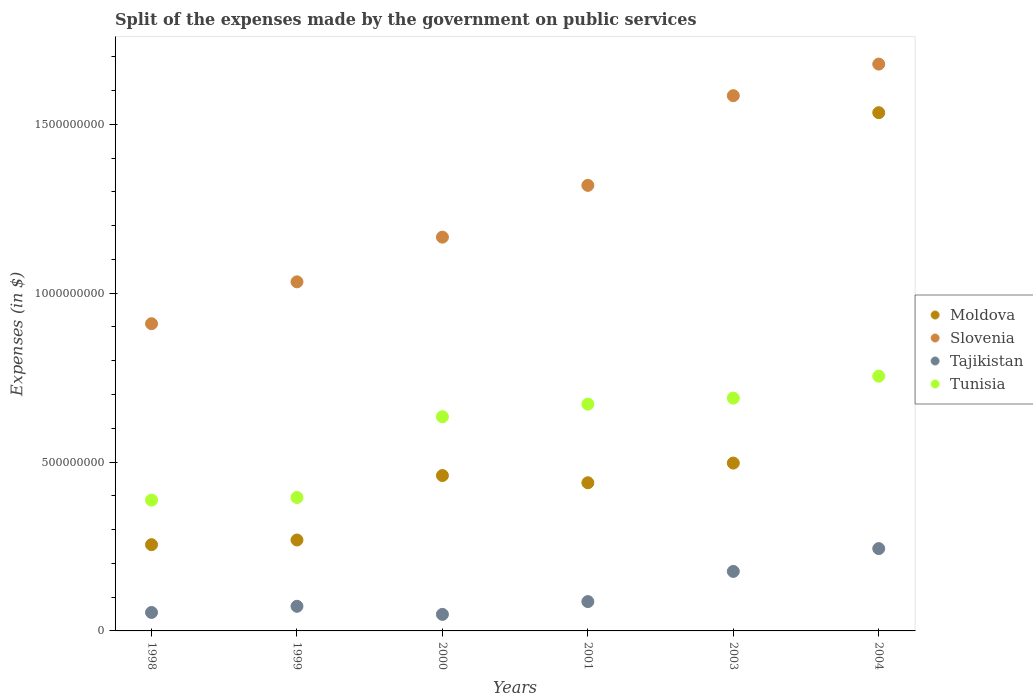How many different coloured dotlines are there?
Give a very brief answer. 4. What is the expenses made by the government on public services in Moldova in 2000?
Your response must be concise. 4.60e+08. Across all years, what is the maximum expenses made by the government on public services in Slovenia?
Your answer should be compact. 1.68e+09. Across all years, what is the minimum expenses made by the government on public services in Tunisia?
Your answer should be compact. 3.87e+08. In which year was the expenses made by the government on public services in Tunisia minimum?
Your answer should be very brief. 1998. What is the total expenses made by the government on public services in Slovenia in the graph?
Your response must be concise. 7.69e+09. What is the difference between the expenses made by the government on public services in Tajikistan in 1998 and that in 1999?
Your response must be concise. -1.82e+07. What is the difference between the expenses made by the government on public services in Moldova in 1998 and the expenses made by the government on public services in Slovenia in 1999?
Ensure brevity in your answer.  -7.78e+08. What is the average expenses made by the government on public services in Moldova per year?
Give a very brief answer. 5.76e+08. In the year 2003, what is the difference between the expenses made by the government on public services in Tajikistan and expenses made by the government on public services in Moldova?
Keep it short and to the point. -3.21e+08. In how many years, is the expenses made by the government on public services in Slovenia greater than 1600000000 $?
Ensure brevity in your answer.  1. What is the ratio of the expenses made by the government on public services in Slovenia in 2001 to that in 2004?
Your answer should be compact. 0.79. Is the expenses made by the government on public services in Slovenia in 1998 less than that in 2004?
Provide a short and direct response. Yes. Is the difference between the expenses made by the government on public services in Tajikistan in 2003 and 2004 greater than the difference between the expenses made by the government on public services in Moldova in 2003 and 2004?
Your answer should be compact. Yes. What is the difference between the highest and the second highest expenses made by the government on public services in Slovenia?
Your answer should be compact. 9.35e+07. What is the difference between the highest and the lowest expenses made by the government on public services in Tunisia?
Your response must be concise. 3.67e+08. In how many years, is the expenses made by the government on public services in Tajikistan greater than the average expenses made by the government on public services in Tajikistan taken over all years?
Give a very brief answer. 2. Is it the case that in every year, the sum of the expenses made by the government on public services in Slovenia and expenses made by the government on public services in Tunisia  is greater than the sum of expenses made by the government on public services in Tajikistan and expenses made by the government on public services in Moldova?
Provide a succinct answer. No. Is the expenses made by the government on public services in Slovenia strictly greater than the expenses made by the government on public services in Tunisia over the years?
Make the answer very short. Yes. Is the expenses made by the government on public services in Tajikistan strictly less than the expenses made by the government on public services in Slovenia over the years?
Your answer should be very brief. Yes. How many dotlines are there?
Offer a very short reply. 4. How many years are there in the graph?
Ensure brevity in your answer.  6. Are the values on the major ticks of Y-axis written in scientific E-notation?
Keep it short and to the point. No. Does the graph contain grids?
Ensure brevity in your answer.  No. Where does the legend appear in the graph?
Your answer should be compact. Center right. What is the title of the graph?
Ensure brevity in your answer.  Split of the expenses made by the government on public services. What is the label or title of the X-axis?
Provide a short and direct response. Years. What is the label or title of the Y-axis?
Keep it short and to the point. Expenses (in $). What is the Expenses (in $) in Moldova in 1998?
Give a very brief answer. 2.55e+08. What is the Expenses (in $) of Slovenia in 1998?
Your answer should be compact. 9.10e+08. What is the Expenses (in $) of Tajikistan in 1998?
Ensure brevity in your answer.  5.47e+07. What is the Expenses (in $) in Tunisia in 1998?
Provide a short and direct response. 3.87e+08. What is the Expenses (in $) in Moldova in 1999?
Your response must be concise. 2.69e+08. What is the Expenses (in $) in Slovenia in 1999?
Provide a short and direct response. 1.03e+09. What is the Expenses (in $) of Tajikistan in 1999?
Your answer should be very brief. 7.29e+07. What is the Expenses (in $) in Tunisia in 1999?
Offer a very short reply. 3.95e+08. What is the Expenses (in $) of Moldova in 2000?
Your answer should be very brief. 4.60e+08. What is the Expenses (in $) in Slovenia in 2000?
Your answer should be compact. 1.17e+09. What is the Expenses (in $) in Tajikistan in 2000?
Ensure brevity in your answer.  4.90e+07. What is the Expenses (in $) of Tunisia in 2000?
Ensure brevity in your answer.  6.34e+08. What is the Expenses (in $) in Moldova in 2001?
Your response must be concise. 4.39e+08. What is the Expenses (in $) of Slovenia in 2001?
Offer a very short reply. 1.32e+09. What is the Expenses (in $) of Tajikistan in 2001?
Make the answer very short. 8.68e+07. What is the Expenses (in $) in Tunisia in 2001?
Your answer should be compact. 6.72e+08. What is the Expenses (in $) of Moldova in 2003?
Provide a succinct answer. 4.97e+08. What is the Expenses (in $) of Slovenia in 2003?
Your answer should be very brief. 1.58e+09. What is the Expenses (in $) in Tajikistan in 2003?
Offer a very short reply. 1.76e+08. What is the Expenses (in $) of Tunisia in 2003?
Give a very brief answer. 6.89e+08. What is the Expenses (in $) in Moldova in 2004?
Your answer should be very brief. 1.53e+09. What is the Expenses (in $) in Slovenia in 2004?
Provide a succinct answer. 1.68e+09. What is the Expenses (in $) of Tajikistan in 2004?
Provide a short and direct response. 2.44e+08. What is the Expenses (in $) in Tunisia in 2004?
Provide a short and direct response. 7.54e+08. Across all years, what is the maximum Expenses (in $) in Moldova?
Your response must be concise. 1.53e+09. Across all years, what is the maximum Expenses (in $) of Slovenia?
Make the answer very short. 1.68e+09. Across all years, what is the maximum Expenses (in $) of Tajikistan?
Make the answer very short. 2.44e+08. Across all years, what is the maximum Expenses (in $) in Tunisia?
Your response must be concise. 7.54e+08. Across all years, what is the minimum Expenses (in $) of Moldova?
Your answer should be compact. 2.55e+08. Across all years, what is the minimum Expenses (in $) in Slovenia?
Provide a succinct answer. 9.10e+08. Across all years, what is the minimum Expenses (in $) of Tajikistan?
Ensure brevity in your answer.  4.90e+07. Across all years, what is the minimum Expenses (in $) in Tunisia?
Keep it short and to the point. 3.87e+08. What is the total Expenses (in $) in Moldova in the graph?
Provide a short and direct response. 3.45e+09. What is the total Expenses (in $) of Slovenia in the graph?
Make the answer very short. 7.69e+09. What is the total Expenses (in $) in Tajikistan in the graph?
Give a very brief answer. 6.83e+08. What is the total Expenses (in $) of Tunisia in the graph?
Offer a very short reply. 3.53e+09. What is the difference between the Expenses (in $) of Moldova in 1998 and that in 1999?
Keep it short and to the point. -1.38e+07. What is the difference between the Expenses (in $) in Slovenia in 1998 and that in 1999?
Ensure brevity in your answer.  -1.24e+08. What is the difference between the Expenses (in $) in Tajikistan in 1998 and that in 1999?
Keep it short and to the point. -1.82e+07. What is the difference between the Expenses (in $) in Tunisia in 1998 and that in 1999?
Your answer should be very brief. -7.80e+06. What is the difference between the Expenses (in $) in Moldova in 1998 and that in 2000?
Offer a terse response. -2.05e+08. What is the difference between the Expenses (in $) in Slovenia in 1998 and that in 2000?
Give a very brief answer. -2.56e+08. What is the difference between the Expenses (in $) of Tajikistan in 1998 and that in 2000?
Make the answer very short. 5.65e+06. What is the difference between the Expenses (in $) in Tunisia in 1998 and that in 2000?
Ensure brevity in your answer.  -2.47e+08. What is the difference between the Expenses (in $) of Moldova in 1998 and that in 2001?
Make the answer very short. -1.83e+08. What is the difference between the Expenses (in $) of Slovenia in 1998 and that in 2001?
Ensure brevity in your answer.  -4.10e+08. What is the difference between the Expenses (in $) of Tajikistan in 1998 and that in 2001?
Offer a very short reply. -3.22e+07. What is the difference between the Expenses (in $) of Tunisia in 1998 and that in 2001?
Provide a short and direct response. -2.84e+08. What is the difference between the Expenses (in $) of Moldova in 1998 and that in 2003?
Give a very brief answer. -2.42e+08. What is the difference between the Expenses (in $) in Slovenia in 1998 and that in 2003?
Your answer should be very brief. -6.75e+08. What is the difference between the Expenses (in $) in Tajikistan in 1998 and that in 2003?
Offer a very short reply. -1.22e+08. What is the difference between the Expenses (in $) of Tunisia in 1998 and that in 2003?
Your response must be concise. -3.02e+08. What is the difference between the Expenses (in $) in Moldova in 1998 and that in 2004?
Keep it short and to the point. -1.28e+09. What is the difference between the Expenses (in $) of Slovenia in 1998 and that in 2004?
Your answer should be very brief. -7.69e+08. What is the difference between the Expenses (in $) of Tajikistan in 1998 and that in 2004?
Your answer should be compact. -1.89e+08. What is the difference between the Expenses (in $) of Tunisia in 1998 and that in 2004?
Your answer should be compact. -3.67e+08. What is the difference between the Expenses (in $) of Moldova in 1999 and that in 2000?
Keep it short and to the point. -1.91e+08. What is the difference between the Expenses (in $) in Slovenia in 1999 and that in 2000?
Your response must be concise. -1.32e+08. What is the difference between the Expenses (in $) in Tajikistan in 1999 and that in 2000?
Keep it short and to the point. 2.39e+07. What is the difference between the Expenses (in $) in Tunisia in 1999 and that in 2000?
Your answer should be very brief. -2.39e+08. What is the difference between the Expenses (in $) in Moldova in 1999 and that in 2001?
Your answer should be very brief. -1.70e+08. What is the difference between the Expenses (in $) of Slovenia in 1999 and that in 2001?
Ensure brevity in your answer.  -2.86e+08. What is the difference between the Expenses (in $) in Tajikistan in 1999 and that in 2001?
Your answer should be compact. -1.39e+07. What is the difference between the Expenses (in $) of Tunisia in 1999 and that in 2001?
Offer a very short reply. -2.76e+08. What is the difference between the Expenses (in $) of Moldova in 1999 and that in 2003?
Keep it short and to the point. -2.28e+08. What is the difference between the Expenses (in $) of Slovenia in 1999 and that in 2003?
Provide a short and direct response. -5.51e+08. What is the difference between the Expenses (in $) in Tajikistan in 1999 and that in 2003?
Your response must be concise. -1.03e+08. What is the difference between the Expenses (in $) of Tunisia in 1999 and that in 2003?
Offer a very short reply. -2.94e+08. What is the difference between the Expenses (in $) in Moldova in 1999 and that in 2004?
Your answer should be very brief. -1.27e+09. What is the difference between the Expenses (in $) of Slovenia in 1999 and that in 2004?
Offer a terse response. -6.45e+08. What is the difference between the Expenses (in $) of Tajikistan in 1999 and that in 2004?
Provide a short and direct response. -1.71e+08. What is the difference between the Expenses (in $) of Tunisia in 1999 and that in 2004?
Your response must be concise. -3.59e+08. What is the difference between the Expenses (in $) of Moldova in 2000 and that in 2001?
Offer a very short reply. 2.14e+07. What is the difference between the Expenses (in $) of Slovenia in 2000 and that in 2001?
Make the answer very short. -1.53e+08. What is the difference between the Expenses (in $) in Tajikistan in 2000 and that in 2001?
Provide a short and direct response. -3.78e+07. What is the difference between the Expenses (in $) of Tunisia in 2000 and that in 2001?
Make the answer very short. -3.73e+07. What is the difference between the Expenses (in $) of Moldova in 2000 and that in 2003?
Make the answer very short. -3.69e+07. What is the difference between the Expenses (in $) in Slovenia in 2000 and that in 2003?
Ensure brevity in your answer.  -4.19e+08. What is the difference between the Expenses (in $) of Tajikistan in 2000 and that in 2003?
Your answer should be compact. -1.27e+08. What is the difference between the Expenses (in $) in Tunisia in 2000 and that in 2003?
Provide a succinct answer. -5.52e+07. What is the difference between the Expenses (in $) in Moldova in 2000 and that in 2004?
Your answer should be compact. -1.07e+09. What is the difference between the Expenses (in $) in Slovenia in 2000 and that in 2004?
Offer a very short reply. -5.12e+08. What is the difference between the Expenses (in $) in Tajikistan in 2000 and that in 2004?
Keep it short and to the point. -1.95e+08. What is the difference between the Expenses (in $) in Tunisia in 2000 and that in 2004?
Offer a very short reply. -1.20e+08. What is the difference between the Expenses (in $) of Moldova in 2001 and that in 2003?
Give a very brief answer. -5.83e+07. What is the difference between the Expenses (in $) of Slovenia in 2001 and that in 2003?
Your answer should be compact. -2.66e+08. What is the difference between the Expenses (in $) in Tajikistan in 2001 and that in 2003?
Provide a short and direct response. -8.94e+07. What is the difference between the Expenses (in $) in Tunisia in 2001 and that in 2003?
Your answer should be compact. -1.79e+07. What is the difference between the Expenses (in $) of Moldova in 2001 and that in 2004?
Offer a terse response. -1.10e+09. What is the difference between the Expenses (in $) in Slovenia in 2001 and that in 2004?
Keep it short and to the point. -3.59e+08. What is the difference between the Expenses (in $) in Tajikistan in 2001 and that in 2004?
Offer a very short reply. -1.57e+08. What is the difference between the Expenses (in $) in Tunisia in 2001 and that in 2004?
Offer a terse response. -8.29e+07. What is the difference between the Expenses (in $) of Moldova in 2003 and that in 2004?
Your response must be concise. -1.04e+09. What is the difference between the Expenses (in $) in Slovenia in 2003 and that in 2004?
Your response must be concise. -9.35e+07. What is the difference between the Expenses (in $) in Tajikistan in 2003 and that in 2004?
Your response must be concise. -6.76e+07. What is the difference between the Expenses (in $) in Tunisia in 2003 and that in 2004?
Provide a short and direct response. -6.50e+07. What is the difference between the Expenses (in $) of Moldova in 1998 and the Expenses (in $) of Slovenia in 1999?
Ensure brevity in your answer.  -7.78e+08. What is the difference between the Expenses (in $) in Moldova in 1998 and the Expenses (in $) in Tajikistan in 1999?
Your answer should be very brief. 1.82e+08. What is the difference between the Expenses (in $) in Moldova in 1998 and the Expenses (in $) in Tunisia in 1999?
Make the answer very short. -1.40e+08. What is the difference between the Expenses (in $) in Slovenia in 1998 and the Expenses (in $) in Tajikistan in 1999?
Your response must be concise. 8.37e+08. What is the difference between the Expenses (in $) in Slovenia in 1998 and the Expenses (in $) in Tunisia in 1999?
Provide a succinct answer. 5.15e+08. What is the difference between the Expenses (in $) of Tajikistan in 1998 and the Expenses (in $) of Tunisia in 1999?
Provide a short and direct response. -3.40e+08. What is the difference between the Expenses (in $) of Moldova in 1998 and the Expenses (in $) of Slovenia in 2000?
Provide a short and direct response. -9.11e+08. What is the difference between the Expenses (in $) in Moldova in 1998 and the Expenses (in $) in Tajikistan in 2000?
Give a very brief answer. 2.06e+08. What is the difference between the Expenses (in $) of Moldova in 1998 and the Expenses (in $) of Tunisia in 2000?
Offer a very short reply. -3.79e+08. What is the difference between the Expenses (in $) in Slovenia in 1998 and the Expenses (in $) in Tajikistan in 2000?
Offer a very short reply. 8.61e+08. What is the difference between the Expenses (in $) in Slovenia in 1998 and the Expenses (in $) in Tunisia in 2000?
Provide a succinct answer. 2.75e+08. What is the difference between the Expenses (in $) of Tajikistan in 1998 and the Expenses (in $) of Tunisia in 2000?
Provide a short and direct response. -5.80e+08. What is the difference between the Expenses (in $) of Moldova in 1998 and the Expenses (in $) of Slovenia in 2001?
Give a very brief answer. -1.06e+09. What is the difference between the Expenses (in $) in Moldova in 1998 and the Expenses (in $) in Tajikistan in 2001?
Provide a succinct answer. 1.69e+08. What is the difference between the Expenses (in $) of Moldova in 1998 and the Expenses (in $) of Tunisia in 2001?
Provide a succinct answer. -4.16e+08. What is the difference between the Expenses (in $) of Slovenia in 1998 and the Expenses (in $) of Tajikistan in 2001?
Your answer should be compact. 8.23e+08. What is the difference between the Expenses (in $) of Slovenia in 1998 and the Expenses (in $) of Tunisia in 2001?
Provide a short and direct response. 2.38e+08. What is the difference between the Expenses (in $) of Tajikistan in 1998 and the Expenses (in $) of Tunisia in 2001?
Provide a short and direct response. -6.17e+08. What is the difference between the Expenses (in $) in Moldova in 1998 and the Expenses (in $) in Slovenia in 2003?
Keep it short and to the point. -1.33e+09. What is the difference between the Expenses (in $) of Moldova in 1998 and the Expenses (in $) of Tajikistan in 2003?
Offer a terse response. 7.92e+07. What is the difference between the Expenses (in $) in Moldova in 1998 and the Expenses (in $) in Tunisia in 2003?
Your answer should be very brief. -4.34e+08. What is the difference between the Expenses (in $) in Slovenia in 1998 and the Expenses (in $) in Tajikistan in 2003?
Your answer should be very brief. 7.33e+08. What is the difference between the Expenses (in $) in Slovenia in 1998 and the Expenses (in $) in Tunisia in 2003?
Your response must be concise. 2.20e+08. What is the difference between the Expenses (in $) in Tajikistan in 1998 and the Expenses (in $) in Tunisia in 2003?
Offer a terse response. -6.35e+08. What is the difference between the Expenses (in $) of Moldova in 1998 and the Expenses (in $) of Slovenia in 2004?
Make the answer very short. -1.42e+09. What is the difference between the Expenses (in $) of Moldova in 1998 and the Expenses (in $) of Tajikistan in 2004?
Keep it short and to the point. 1.16e+07. What is the difference between the Expenses (in $) of Moldova in 1998 and the Expenses (in $) of Tunisia in 2004?
Make the answer very short. -4.99e+08. What is the difference between the Expenses (in $) in Slovenia in 1998 and the Expenses (in $) in Tajikistan in 2004?
Your response must be concise. 6.66e+08. What is the difference between the Expenses (in $) of Slovenia in 1998 and the Expenses (in $) of Tunisia in 2004?
Your answer should be very brief. 1.55e+08. What is the difference between the Expenses (in $) in Tajikistan in 1998 and the Expenses (in $) in Tunisia in 2004?
Make the answer very short. -7.00e+08. What is the difference between the Expenses (in $) in Moldova in 1999 and the Expenses (in $) in Slovenia in 2000?
Your answer should be compact. -8.97e+08. What is the difference between the Expenses (in $) in Moldova in 1999 and the Expenses (in $) in Tajikistan in 2000?
Keep it short and to the point. 2.20e+08. What is the difference between the Expenses (in $) in Moldova in 1999 and the Expenses (in $) in Tunisia in 2000?
Your answer should be compact. -3.65e+08. What is the difference between the Expenses (in $) of Slovenia in 1999 and the Expenses (in $) of Tajikistan in 2000?
Ensure brevity in your answer.  9.85e+08. What is the difference between the Expenses (in $) of Slovenia in 1999 and the Expenses (in $) of Tunisia in 2000?
Make the answer very short. 3.99e+08. What is the difference between the Expenses (in $) of Tajikistan in 1999 and the Expenses (in $) of Tunisia in 2000?
Keep it short and to the point. -5.61e+08. What is the difference between the Expenses (in $) of Moldova in 1999 and the Expenses (in $) of Slovenia in 2001?
Your answer should be very brief. -1.05e+09. What is the difference between the Expenses (in $) in Moldova in 1999 and the Expenses (in $) in Tajikistan in 2001?
Keep it short and to the point. 1.82e+08. What is the difference between the Expenses (in $) in Moldova in 1999 and the Expenses (in $) in Tunisia in 2001?
Make the answer very short. -4.02e+08. What is the difference between the Expenses (in $) of Slovenia in 1999 and the Expenses (in $) of Tajikistan in 2001?
Make the answer very short. 9.47e+08. What is the difference between the Expenses (in $) in Slovenia in 1999 and the Expenses (in $) in Tunisia in 2001?
Offer a very short reply. 3.62e+08. What is the difference between the Expenses (in $) of Tajikistan in 1999 and the Expenses (in $) of Tunisia in 2001?
Make the answer very short. -5.99e+08. What is the difference between the Expenses (in $) in Moldova in 1999 and the Expenses (in $) in Slovenia in 2003?
Ensure brevity in your answer.  -1.32e+09. What is the difference between the Expenses (in $) of Moldova in 1999 and the Expenses (in $) of Tajikistan in 2003?
Your answer should be compact. 9.30e+07. What is the difference between the Expenses (in $) of Moldova in 1999 and the Expenses (in $) of Tunisia in 2003?
Your answer should be very brief. -4.20e+08. What is the difference between the Expenses (in $) in Slovenia in 1999 and the Expenses (in $) in Tajikistan in 2003?
Make the answer very short. 8.57e+08. What is the difference between the Expenses (in $) in Slovenia in 1999 and the Expenses (in $) in Tunisia in 2003?
Offer a terse response. 3.44e+08. What is the difference between the Expenses (in $) of Tajikistan in 1999 and the Expenses (in $) of Tunisia in 2003?
Your answer should be compact. -6.16e+08. What is the difference between the Expenses (in $) of Moldova in 1999 and the Expenses (in $) of Slovenia in 2004?
Your answer should be compact. -1.41e+09. What is the difference between the Expenses (in $) of Moldova in 1999 and the Expenses (in $) of Tajikistan in 2004?
Your answer should be compact. 2.54e+07. What is the difference between the Expenses (in $) in Moldova in 1999 and the Expenses (in $) in Tunisia in 2004?
Provide a succinct answer. -4.85e+08. What is the difference between the Expenses (in $) in Slovenia in 1999 and the Expenses (in $) in Tajikistan in 2004?
Your answer should be compact. 7.90e+08. What is the difference between the Expenses (in $) in Slovenia in 1999 and the Expenses (in $) in Tunisia in 2004?
Offer a terse response. 2.79e+08. What is the difference between the Expenses (in $) of Tajikistan in 1999 and the Expenses (in $) of Tunisia in 2004?
Give a very brief answer. -6.81e+08. What is the difference between the Expenses (in $) of Moldova in 2000 and the Expenses (in $) of Slovenia in 2001?
Give a very brief answer. -8.59e+08. What is the difference between the Expenses (in $) of Moldova in 2000 and the Expenses (in $) of Tajikistan in 2001?
Make the answer very short. 3.73e+08. What is the difference between the Expenses (in $) in Moldova in 2000 and the Expenses (in $) in Tunisia in 2001?
Provide a succinct answer. -2.11e+08. What is the difference between the Expenses (in $) of Slovenia in 2000 and the Expenses (in $) of Tajikistan in 2001?
Offer a very short reply. 1.08e+09. What is the difference between the Expenses (in $) of Slovenia in 2000 and the Expenses (in $) of Tunisia in 2001?
Your answer should be compact. 4.94e+08. What is the difference between the Expenses (in $) of Tajikistan in 2000 and the Expenses (in $) of Tunisia in 2001?
Keep it short and to the point. -6.22e+08. What is the difference between the Expenses (in $) of Moldova in 2000 and the Expenses (in $) of Slovenia in 2003?
Your response must be concise. -1.12e+09. What is the difference between the Expenses (in $) in Moldova in 2000 and the Expenses (in $) in Tajikistan in 2003?
Keep it short and to the point. 2.84e+08. What is the difference between the Expenses (in $) in Moldova in 2000 and the Expenses (in $) in Tunisia in 2003?
Your response must be concise. -2.29e+08. What is the difference between the Expenses (in $) in Slovenia in 2000 and the Expenses (in $) in Tajikistan in 2003?
Provide a short and direct response. 9.90e+08. What is the difference between the Expenses (in $) in Slovenia in 2000 and the Expenses (in $) in Tunisia in 2003?
Ensure brevity in your answer.  4.77e+08. What is the difference between the Expenses (in $) of Tajikistan in 2000 and the Expenses (in $) of Tunisia in 2003?
Offer a very short reply. -6.40e+08. What is the difference between the Expenses (in $) in Moldova in 2000 and the Expenses (in $) in Slovenia in 2004?
Your answer should be compact. -1.22e+09. What is the difference between the Expenses (in $) of Moldova in 2000 and the Expenses (in $) of Tajikistan in 2004?
Keep it short and to the point. 2.16e+08. What is the difference between the Expenses (in $) of Moldova in 2000 and the Expenses (in $) of Tunisia in 2004?
Offer a terse response. -2.94e+08. What is the difference between the Expenses (in $) in Slovenia in 2000 and the Expenses (in $) in Tajikistan in 2004?
Provide a short and direct response. 9.22e+08. What is the difference between the Expenses (in $) in Slovenia in 2000 and the Expenses (in $) in Tunisia in 2004?
Keep it short and to the point. 4.12e+08. What is the difference between the Expenses (in $) in Tajikistan in 2000 and the Expenses (in $) in Tunisia in 2004?
Your answer should be very brief. -7.05e+08. What is the difference between the Expenses (in $) of Moldova in 2001 and the Expenses (in $) of Slovenia in 2003?
Your response must be concise. -1.15e+09. What is the difference between the Expenses (in $) of Moldova in 2001 and the Expenses (in $) of Tajikistan in 2003?
Provide a succinct answer. 2.62e+08. What is the difference between the Expenses (in $) of Moldova in 2001 and the Expenses (in $) of Tunisia in 2003?
Make the answer very short. -2.51e+08. What is the difference between the Expenses (in $) of Slovenia in 2001 and the Expenses (in $) of Tajikistan in 2003?
Provide a short and direct response. 1.14e+09. What is the difference between the Expenses (in $) of Slovenia in 2001 and the Expenses (in $) of Tunisia in 2003?
Your answer should be very brief. 6.30e+08. What is the difference between the Expenses (in $) in Tajikistan in 2001 and the Expenses (in $) in Tunisia in 2003?
Ensure brevity in your answer.  -6.03e+08. What is the difference between the Expenses (in $) in Moldova in 2001 and the Expenses (in $) in Slovenia in 2004?
Keep it short and to the point. -1.24e+09. What is the difference between the Expenses (in $) in Moldova in 2001 and the Expenses (in $) in Tajikistan in 2004?
Give a very brief answer. 1.95e+08. What is the difference between the Expenses (in $) in Moldova in 2001 and the Expenses (in $) in Tunisia in 2004?
Keep it short and to the point. -3.16e+08. What is the difference between the Expenses (in $) in Slovenia in 2001 and the Expenses (in $) in Tajikistan in 2004?
Keep it short and to the point. 1.08e+09. What is the difference between the Expenses (in $) of Slovenia in 2001 and the Expenses (in $) of Tunisia in 2004?
Give a very brief answer. 5.65e+08. What is the difference between the Expenses (in $) in Tajikistan in 2001 and the Expenses (in $) in Tunisia in 2004?
Give a very brief answer. -6.68e+08. What is the difference between the Expenses (in $) of Moldova in 2003 and the Expenses (in $) of Slovenia in 2004?
Offer a very short reply. -1.18e+09. What is the difference between the Expenses (in $) of Moldova in 2003 and the Expenses (in $) of Tajikistan in 2004?
Provide a short and direct response. 2.53e+08. What is the difference between the Expenses (in $) in Moldova in 2003 and the Expenses (in $) in Tunisia in 2004?
Provide a short and direct response. -2.57e+08. What is the difference between the Expenses (in $) of Slovenia in 2003 and the Expenses (in $) of Tajikistan in 2004?
Provide a short and direct response. 1.34e+09. What is the difference between the Expenses (in $) in Slovenia in 2003 and the Expenses (in $) in Tunisia in 2004?
Make the answer very short. 8.30e+08. What is the difference between the Expenses (in $) in Tajikistan in 2003 and the Expenses (in $) in Tunisia in 2004?
Keep it short and to the point. -5.78e+08. What is the average Expenses (in $) of Moldova per year?
Offer a very short reply. 5.76e+08. What is the average Expenses (in $) in Slovenia per year?
Provide a short and direct response. 1.28e+09. What is the average Expenses (in $) in Tajikistan per year?
Your response must be concise. 1.14e+08. What is the average Expenses (in $) in Tunisia per year?
Offer a terse response. 5.89e+08. In the year 1998, what is the difference between the Expenses (in $) in Moldova and Expenses (in $) in Slovenia?
Keep it short and to the point. -6.54e+08. In the year 1998, what is the difference between the Expenses (in $) in Moldova and Expenses (in $) in Tajikistan?
Provide a short and direct response. 2.01e+08. In the year 1998, what is the difference between the Expenses (in $) in Moldova and Expenses (in $) in Tunisia?
Your answer should be very brief. -1.32e+08. In the year 1998, what is the difference between the Expenses (in $) in Slovenia and Expenses (in $) in Tajikistan?
Make the answer very short. 8.55e+08. In the year 1998, what is the difference between the Expenses (in $) in Slovenia and Expenses (in $) in Tunisia?
Your answer should be very brief. 5.22e+08. In the year 1998, what is the difference between the Expenses (in $) in Tajikistan and Expenses (in $) in Tunisia?
Provide a short and direct response. -3.33e+08. In the year 1999, what is the difference between the Expenses (in $) in Moldova and Expenses (in $) in Slovenia?
Keep it short and to the point. -7.64e+08. In the year 1999, what is the difference between the Expenses (in $) in Moldova and Expenses (in $) in Tajikistan?
Offer a very short reply. 1.96e+08. In the year 1999, what is the difference between the Expenses (in $) of Moldova and Expenses (in $) of Tunisia?
Provide a succinct answer. -1.26e+08. In the year 1999, what is the difference between the Expenses (in $) of Slovenia and Expenses (in $) of Tajikistan?
Give a very brief answer. 9.61e+08. In the year 1999, what is the difference between the Expenses (in $) in Slovenia and Expenses (in $) in Tunisia?
Offer a terse response. 6.39e+08. In the year 1999, what is the difference between the Expenses (in $) of Tajikistan and Expenses (in $) of Tunisia?
Make the answer very short. -3.22e+08. In the year 2000, what is the difference between the Expenses (in $) of Moldova and Expenses (in $) of Slovenia?
Provide a short and direct response. -7.06e+08. In the year 2000, what is the difference between the Expenses (in $) of Moldova and Expenses (in $) of Tajikistan?
Your answer should be compact. 4.11e+08. In the year 2000, what is the difference between the Expenses (in $) of Moldova and Expenses (in $) of Tunisia?
Provide a short and direct response. -1.74e+08. In the year 2000, what is the difference between the Expenses (in $) in Slovenia and Expenses (in $) in Tajikistan?
Offer a terse response. 1.12e+09. In the year 2000, what is the difference between the Expenses (in $) of Slovenia and Expenses (in $) of Tunisia?
Offer a very short reply. 5.32e+08. In the year 2000, what is the difference between the Expenses (in $) of Tajikistan and Expenses (in $) of Tunisia?
Keep it short and to the point. -5.85e+08. In the year 2001, what is the difference between the Expenses (in $) in Moldova and Expenses (in $) in Slovenia?
Provide a succinct answer. -8.81e+08. In the year 2001, what is the difference between the Expenses (in $) in Moldova and Expenses (in $) in Tajikistan?
Your answer should be compact. 3.52e+08. In the year 2001, what is the difference between the Expenses (in $) of Moldova and Expenses (in $) of Tunisia?
Make the answer very short. -2.33e+08. In the year 2001, what is the difference between the Expenses (in $) in Slovenia and Expenses (in $) in Tajikistan?
Keep it short and to the point. 1.23e+09. In the year 2001, what is the difference between the Expenses (in $) in Slovenia and Expenses (in $) in Tunisia?
Ensure brevity in your answer.  6.48e+08. In the year 2001, what is the difference between the Expenses (in $) of Tajikistan and Expenses (in $) of Tunisia?
Offer a very short reply. -5.85e+08. In the year 2003, what is the difference between the Expenses (in $) in Moldova and Expenses (in $) in Slovenia?
Give a very brief answer. -1.09e+09. In the year 2003, what is the difference between the Expenses (in $) in Moldova and Expenses (in $) in Tajikistan?
Your response must be concise. 3.21e+08. In the year 2003, what is the difference between the Expenses (in $) in Moldova and Expenses (in $) in Tunisia?
Offer a very short reply. -1.92e+08. In the year 2003, what is the difference between the Expenses (in $) in Slovenia and Expenses (in $) in Tajikistan?
Keep it short and to the point. 1.41e+09. In the year 2003, what is the difference between the Expenses (in $) in Slovenia and Expenses (in $) in Tunisia?
Your answer should be very brief. 8.95e+08. In the year 2003, what is the difference between the Expenses (in $) in Tajikistan and Expenses (in $) in Tunisia?
Give a very brief answer. -5.13e+08. In the year 2004, what is the difference between the Expenses (in $) of Moldova and Expenses (in $) of Slovenia?
Your answer should be very brief. -1.44e+08. In the year 2004, what is the difference between the Expenses (in $) in Moldova and Expenses (in $) in Tajikistan?
Your answer should be very brief. 1.29e+09. In the year 2004, what is the difference between the Expenses (in $) of Moldova and Expenses (in $) of Tunisia?
Give a very brief answer. 7.80e+08. In the year 2004, what is the difference between the Expenses (in $) of Slovenia and Expenses (in $) of Tajikistan?
Your answer should be very brief. 1.43e+09. In the year 2004, what is the difference between the Expenses (in $) of Slovenia and Expenses (in $) of Tunisia?
Give a very brief answer. 9.24e+08. In the year 2004, what is the difference between the Expenses (in $) of Tajikistan and Expenses (in $) of Tunisia?
Your answer should be very brief. -5.11e+08. What is the ratio of the Expenses (in $) of Moldova in 1998 to that in 1999?
Ensure brevity in your answer.  0.95. What is the ratio of the Expenses (in $) in Slovenia in 1998 to that in 1999?
Offer a terse response. 0.88. What is the ratio of the Expenses (in $) in Tajikistan in 1998 to that in 1999?
Your response must be concise. 0.75. What is the ratio of the Expenses (in $) in Tunisia in 1998 to that in 1999?
Ensure brevity in your answer.  0.98. What is the ratio of the Expenses (in $) of Moldova in 1998 to that in 2000?
Ensure brevity in your answer.  0.56. What is the ratio of the Expenses (in $) in Slovenia in 1998 to that in 2000?
Give a very brief answer. 0.78. What is the ratio of the Expenses (in $) of Tajikistan in 1998 to that in 2000?
Your answer should be compact. 1.12. What is the ratio of the Expenses (in $) in Tunisia in 1998 to that in 2000?
Make the answer very short. 0.61. What is the ratio of the Expenses (in $) in Moldova in 1998 to that in 2001?
Your answer should be very brief. 0.58. What is the ratio of the Expenses (in $) of Slovenia in 1998 to that in 2001?
Provide a short and direct response. 0.69. What is the ratio of the Expenses (in $) in Tajikistan in 1998 to that in 2001?
Keep it short and to the point. 0.63. What is the ratio of the Expenses (in $) of Tunisia in 1998 to that in 2001?
Keep it short and to the point. 0.58. What is the ratio of the Expenses (in $) in Moldova in 1998 to that in 2003?
Provide a short and direct response. 0.51. What is the ratio of the Expenses (in $) in Slovenia in 1998 to that in 2003?
Keep it short and to the point. 0.57. What is the ratio of the Expenses (in $) of Tajikistan in 1998 to that in 2003?
Your answer should be very brief. 0.31. What is the ratio of the Expenses (in $) of Tunisia in 1998 to that in 2003?
Your response must be concise. 0.56. What is the ratio of the Expenses (in $) of Moldova in 1998 to that in 2004?
Make the answer very short. 0.17. What is the ratio of the Expenses (in $) of Slovenia in 1998 to that in 2004?
Provide a short and direct response. 0.54. What is the ratio of the Expenses (in $) in Tajikistan in 1998 to that in 2004?
Give a very brief answer. 0.22. What is the ratio of the Expenses (in $) of Tunisia in 1998 to that in 2004?
Offer a terse response. 0.51. What is the ratio of the Expenses (in $) of Moldova in 1999 to that in 2000?
Provide a succinct answer. 0.59. What is the ratio of the Expenses (in $) of Slovenia in 1999 to that in 2000?
Provide a short and direct response. 0.89. What is the ratio of the Expenses (in $) in Tajikistan in 1999 to that in 2000?
Provide a short and direct response. 1.49. What is the ratio of the Expenses (in $) of Tunisia in 1999 to that in 2000?
Offer a terse response. 0.62. What is the ratio of the Expenses (in $) in Moldova in 1999 to that in 2001?
Ensure brevity in your answer.  0.61. What is the ratio of the Expenses (in $) of Slovenia in 1999 to that in 2001?
Offer a very short reply. 0.78. What is the ratio of the Expenses (in $) of Tajikistan in 1999 to that in 2001?
Keep it short and to the point. 0.84. What is the ratio of the Expenses (in $) of Tunisia in 1999 to that in 2001?
Keep it short and to the point. 0.59. What is the ratio of the Expenses (in $) of Moldova in 1999 to that in 2003?
Ensure brevity in your answer.  0.54. What is the ratio of the Expenses (in $) of Slovenia in 1999 to that in 2003?
Offer a very short reply. 0.65. What is the ratio of the Expenses (in $) in Tajikistan in 1999 to that in 2003?
Your answer should be compact. 0.41. What is the ratio of the Expenses (in $) of Tunisia in 1999 to that in 2003?
Give a very brief answer. 0.57. What is the ratio of the Expenses (in $) in Moldova in 1999 to that in 2004?
Make the answer very short. 0.18. What is the ratio of the Expenses (in $) of Slovenia in 1999 to that in 2004?
Your answer should be compact. 0.62. What is the ratio of the Expenses (in $) in Tajikistan in 1999 to that in 2004?
Provide a short and direct response. 0.3. What is the ratio of the Expenses (in $) in Tunisia in 1999 to that in 2004?
Offer a terse response. 0.52. What is the ratio of the Expenses (in $) in Moldova in 2000 to that in 2001?
Your response must be concise. 1.05. What is the ratio of the Expenses (in $) of Slovenia in 2000 to that in 2001?
Keep it short and to the point. 0.88. What is the ratio of the Expenses (in $) of Tajikistan in 2000 to that in 2001?
Your answer should be compact. 0.56. What is the ratio of the Expenses (in $) of Tunisia in 2000 to that in 2001?
Make the answer very short. 0.94. What is the ratio of the Expenses (in $) of Moldova in 2000 to that in 2003?
Keep it short and to the point. 0.93. What is the ratio of the Expenses (in $) of Slovenia in 2000 to that in 2003?
Give a very brief answer. 0.74. What is the ratio of the Expenses (in $) of Tajikistan in 2000 to that in 2003?
Your answer should be very brief. 0.28. What is the ratio of the Expenses (in $) of Tunisia in 2000 to that in 2003?
Your answer should be compact. 0.92. What is the ratio of the Expenses (in $) of Moldova in 2000 to that in 2004?
Your answer should be compact. 0.3. What is the ratio of the Expenses (in $) of Slovenia in 2000 to that in 2004?
Make the answer very short. 0.69. What is the ratio of the Expenses (in $) of Tajikistan in 2000 to that in 2004?
Ensure brevity in your answer.  0.2. What is the ratio of the Expenses (in $) in Tunisia in 2000 to that in 2004?
Give a very brief answer. 0.84. What is the ratio of the Expenses (in $) in Moldova in 2001 to that in 2003?
Offer a terse response. 0.88. What is the ratio of the Expenses (in $) in Slovenia in 2001 to that in 2003?
Provide a short and direct response. 0.83. What is the ratio of the Expenses (in $) of Tajikistan in 2001 to that in 2003?
Provide a short and direct response. 0.49. What is the ratio of the Expenses (in $) in Moldova in 2001 to that in 2004?
Give a very brief answer. 0.29. What is the ratio of the Expenses (in $) in Slovenia in 2001 to that in 2004?
Make the answer very short. 0.79. What is the ratio of the Expenses (in $) of Tajikistan in 2001 to that in 2004?
Your response must be concise. 0.36. What is the ratio of the Expenses (in $) of Tunisia in 2001 to that in 2004?
Your answer should be compact. 0.89. What is the ratio of the Expenses (in $) in Moldova in 2003 to that in 2004?
Ensure brevity in your answer.  0.32. What is the ratio of the Expenses (in $) of Slovenia in 2003 to that in 2004?
Provide a succinct answer. 0.94. What is the ratio of the Expenses (in $) of Tajikistan in 2003 to that in 2004?
Offer a terse response. 0.72. What is the ratio of the Expenses (in $) in Tunisia in 2003 to that in 2004?
Your answer should be very brief. 0.91. What is the difference between the highest and the second highest Expenses (in $) of Moldova?
Keep it short and to the point. 1.04e+09. What is the difference between the highest and the second highest Expenses (in $) of Slovenia?
Offer a terse response. 9.35e+07. What is the difference between the highest and the second highest Expenses (in $) of Tajikistan?
Your response must be concise. 6.76e+07. What is the difference between the highest and the second highest Expenses (in $) of Tunisia?
Offer a terse response. 6.50e+07. What is the difference between the highest and the lowest Expenses (in $) of Moldova?
Offer a very short reply. 1.28e+09. What is the difference between the highest and the lowest Expenses (in $) in Slovenia?
Offer a very short reply. 7.69e+08. What is the difference between the highest and the lowest Expenses (in $) of Tajikistan?
Your response must be concise. 1.95e+08. What is the difference between the highest and the lowest Expenses (in $) of Tunisia?
Your answer should be very brief. 3.67e+08. 